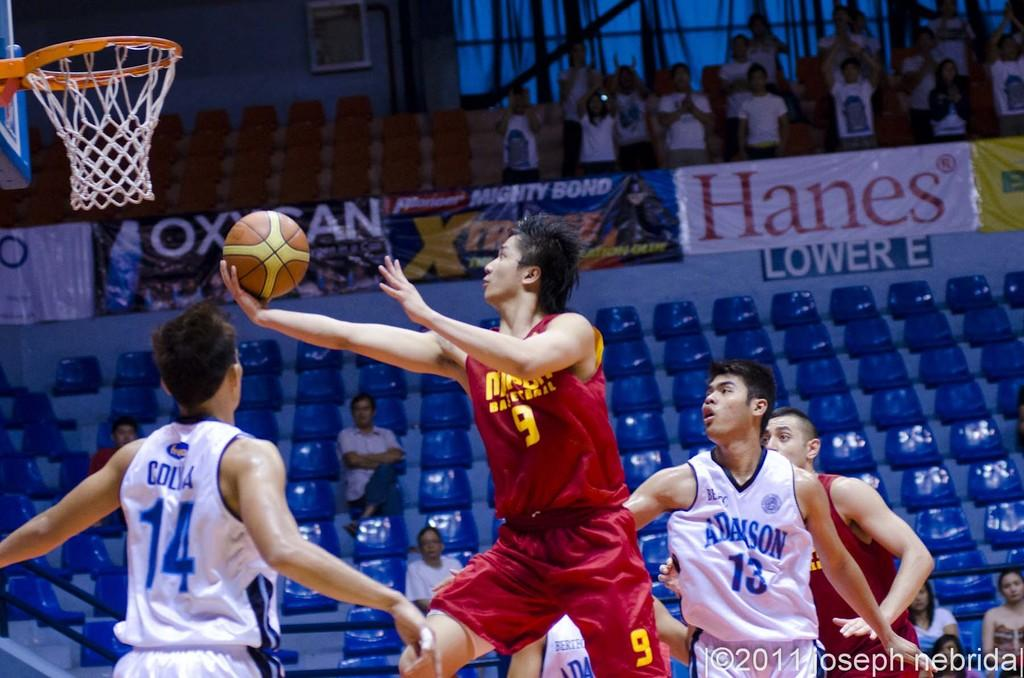How many people are in the image? There are people in the image, but the exact number is not specified. What is one person holding in the image? One person is holding a ball in the image. What can be seen in the background of the image? The background of the image includes people, chairs, and a wall. What is the purpose of the basketball hoop in the image? The basketball hoop suggests that the people in the image might be playing basketball or engaging in a related activity. What type of song is being sung by the people in the image? There is no indication in the image that the people are singing a song, so it cannot be determined from the picture. 